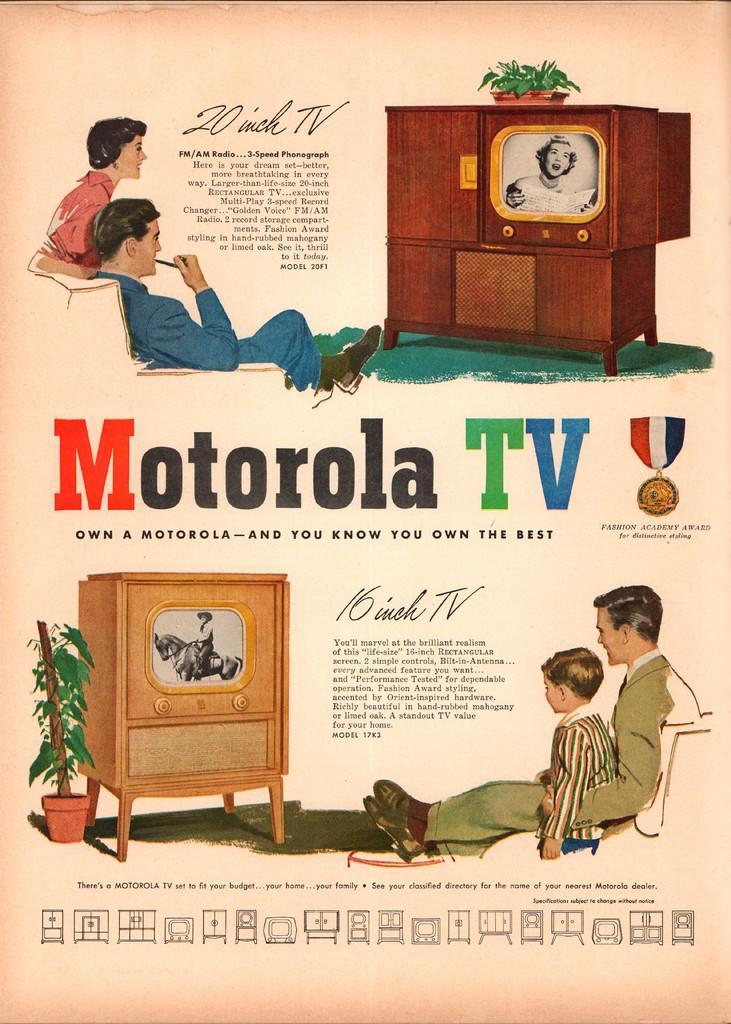Could you give a brief overview of what you see in this image? In this image, we can see a poster, on that poster we can see some pictures and text. 